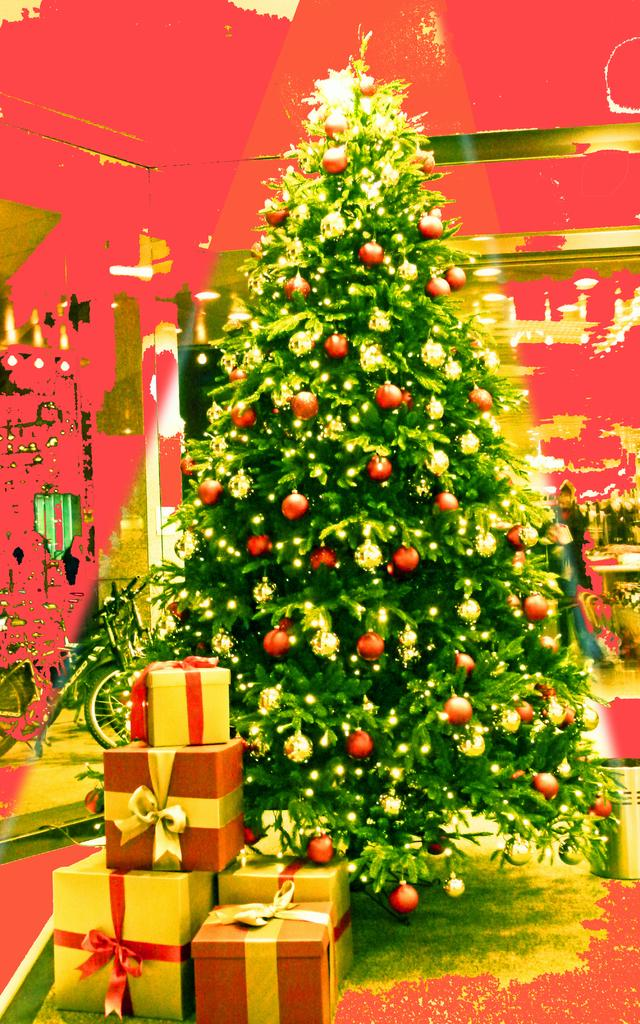What is the main subject of the image? There is a Christmas tree in the image. What can be seen on the Christmas tree? The Christmas tree has decorative objects. What else is present in the image besides the tree? There are gifts and ribbons in the image. Can you describe the background of the image? There are unspecified objects in the background of the image. What type of trousers can be seen hanging on the Christmas tree in the image? There are no trousers present on the Christmas tree or in the image. What musical band is performing in the background of the image? There is no musical band present in the image; it features a Christmas tree, gifts, and ribbons. 